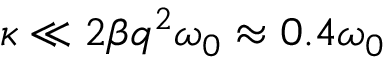Convert formula to latex. <formula><loc_0><loc_0><loc_500><loc_500>\kappa \ll 2 \beta q ^ { 2 } \omega _ { 0 } \approx 0 . 4 \omega _ { 0 }</formula> 